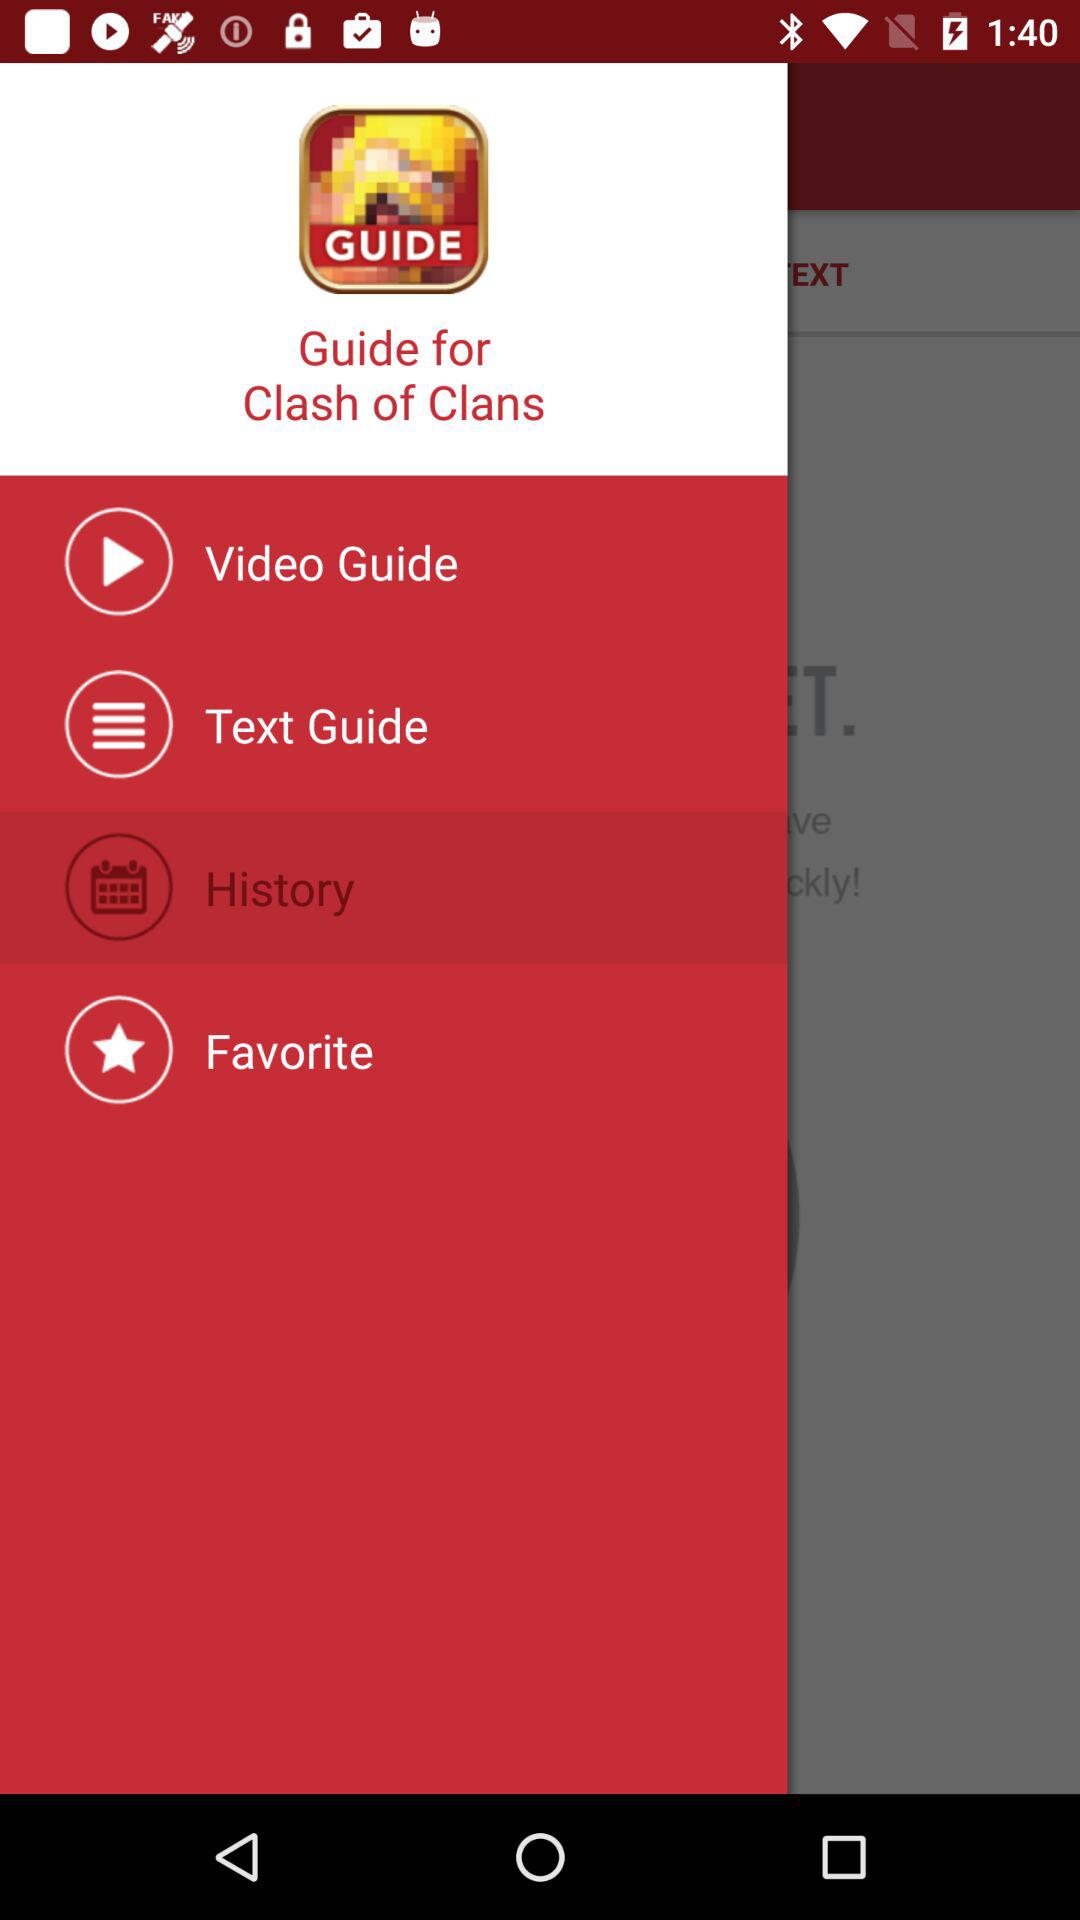What is the selected item in the menu? The selected item in the menu is "History". 